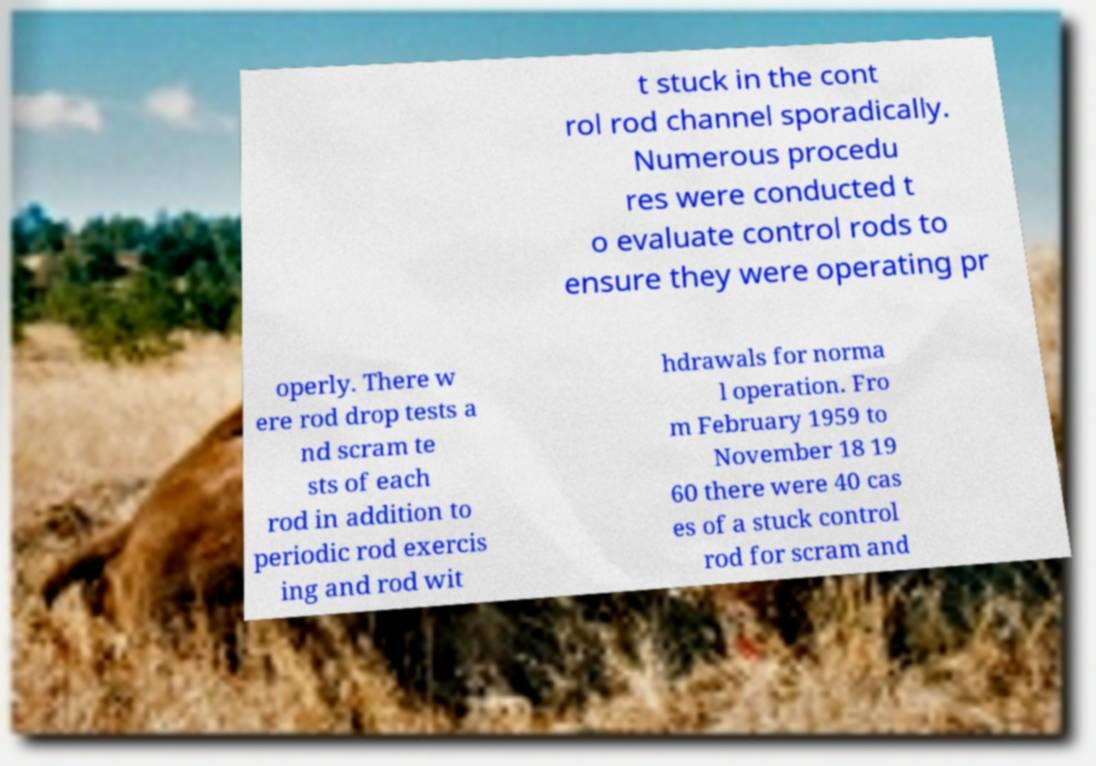Can you read and provide the text displayed in the image?This photo seems to have some interesting text. Can you extract and type it out for me? t stuck in the cont rol rod channel sporadically. Numerous procedu res were conducted t o evaluate control rods to ensure they were operating pr operly. There w ere rod drop tests a nd scram te sts of each rod in addition to periodic rod exercis ing and rod wit hdrawals for norma l operation. Fro m February 1959 to November 18 19 60 there were 40 cas es of a stuck control rod for scram and 